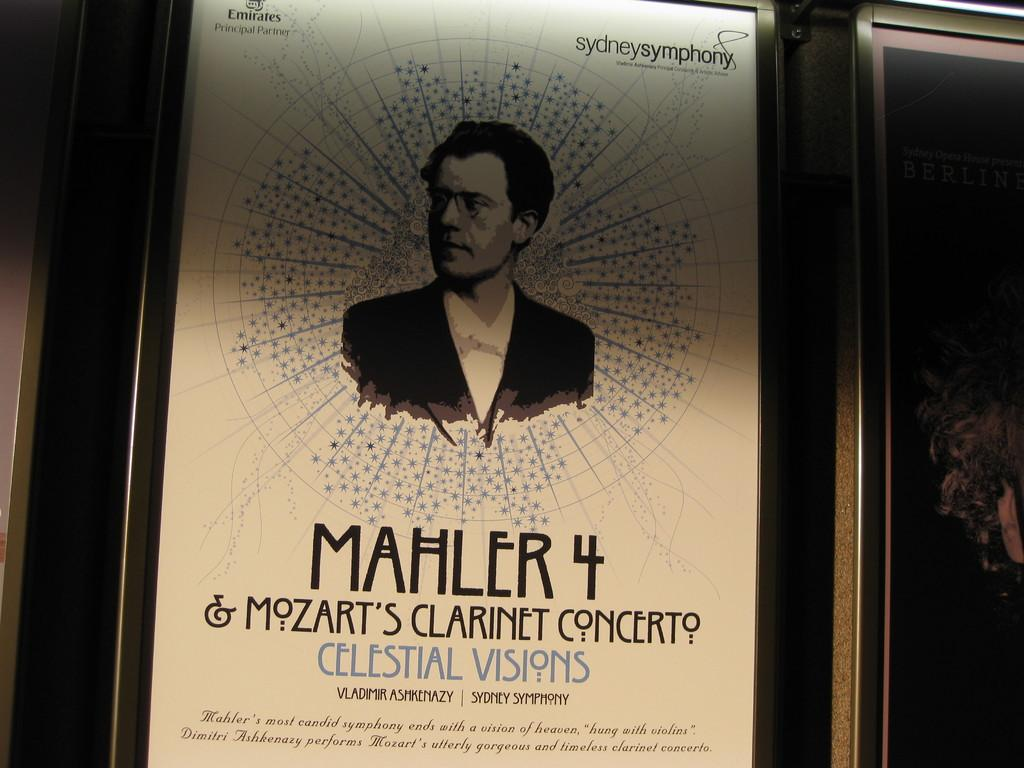Provide a one-sentence caption for the provided image. An old poster for Sydney Symphony Mahler 4. 